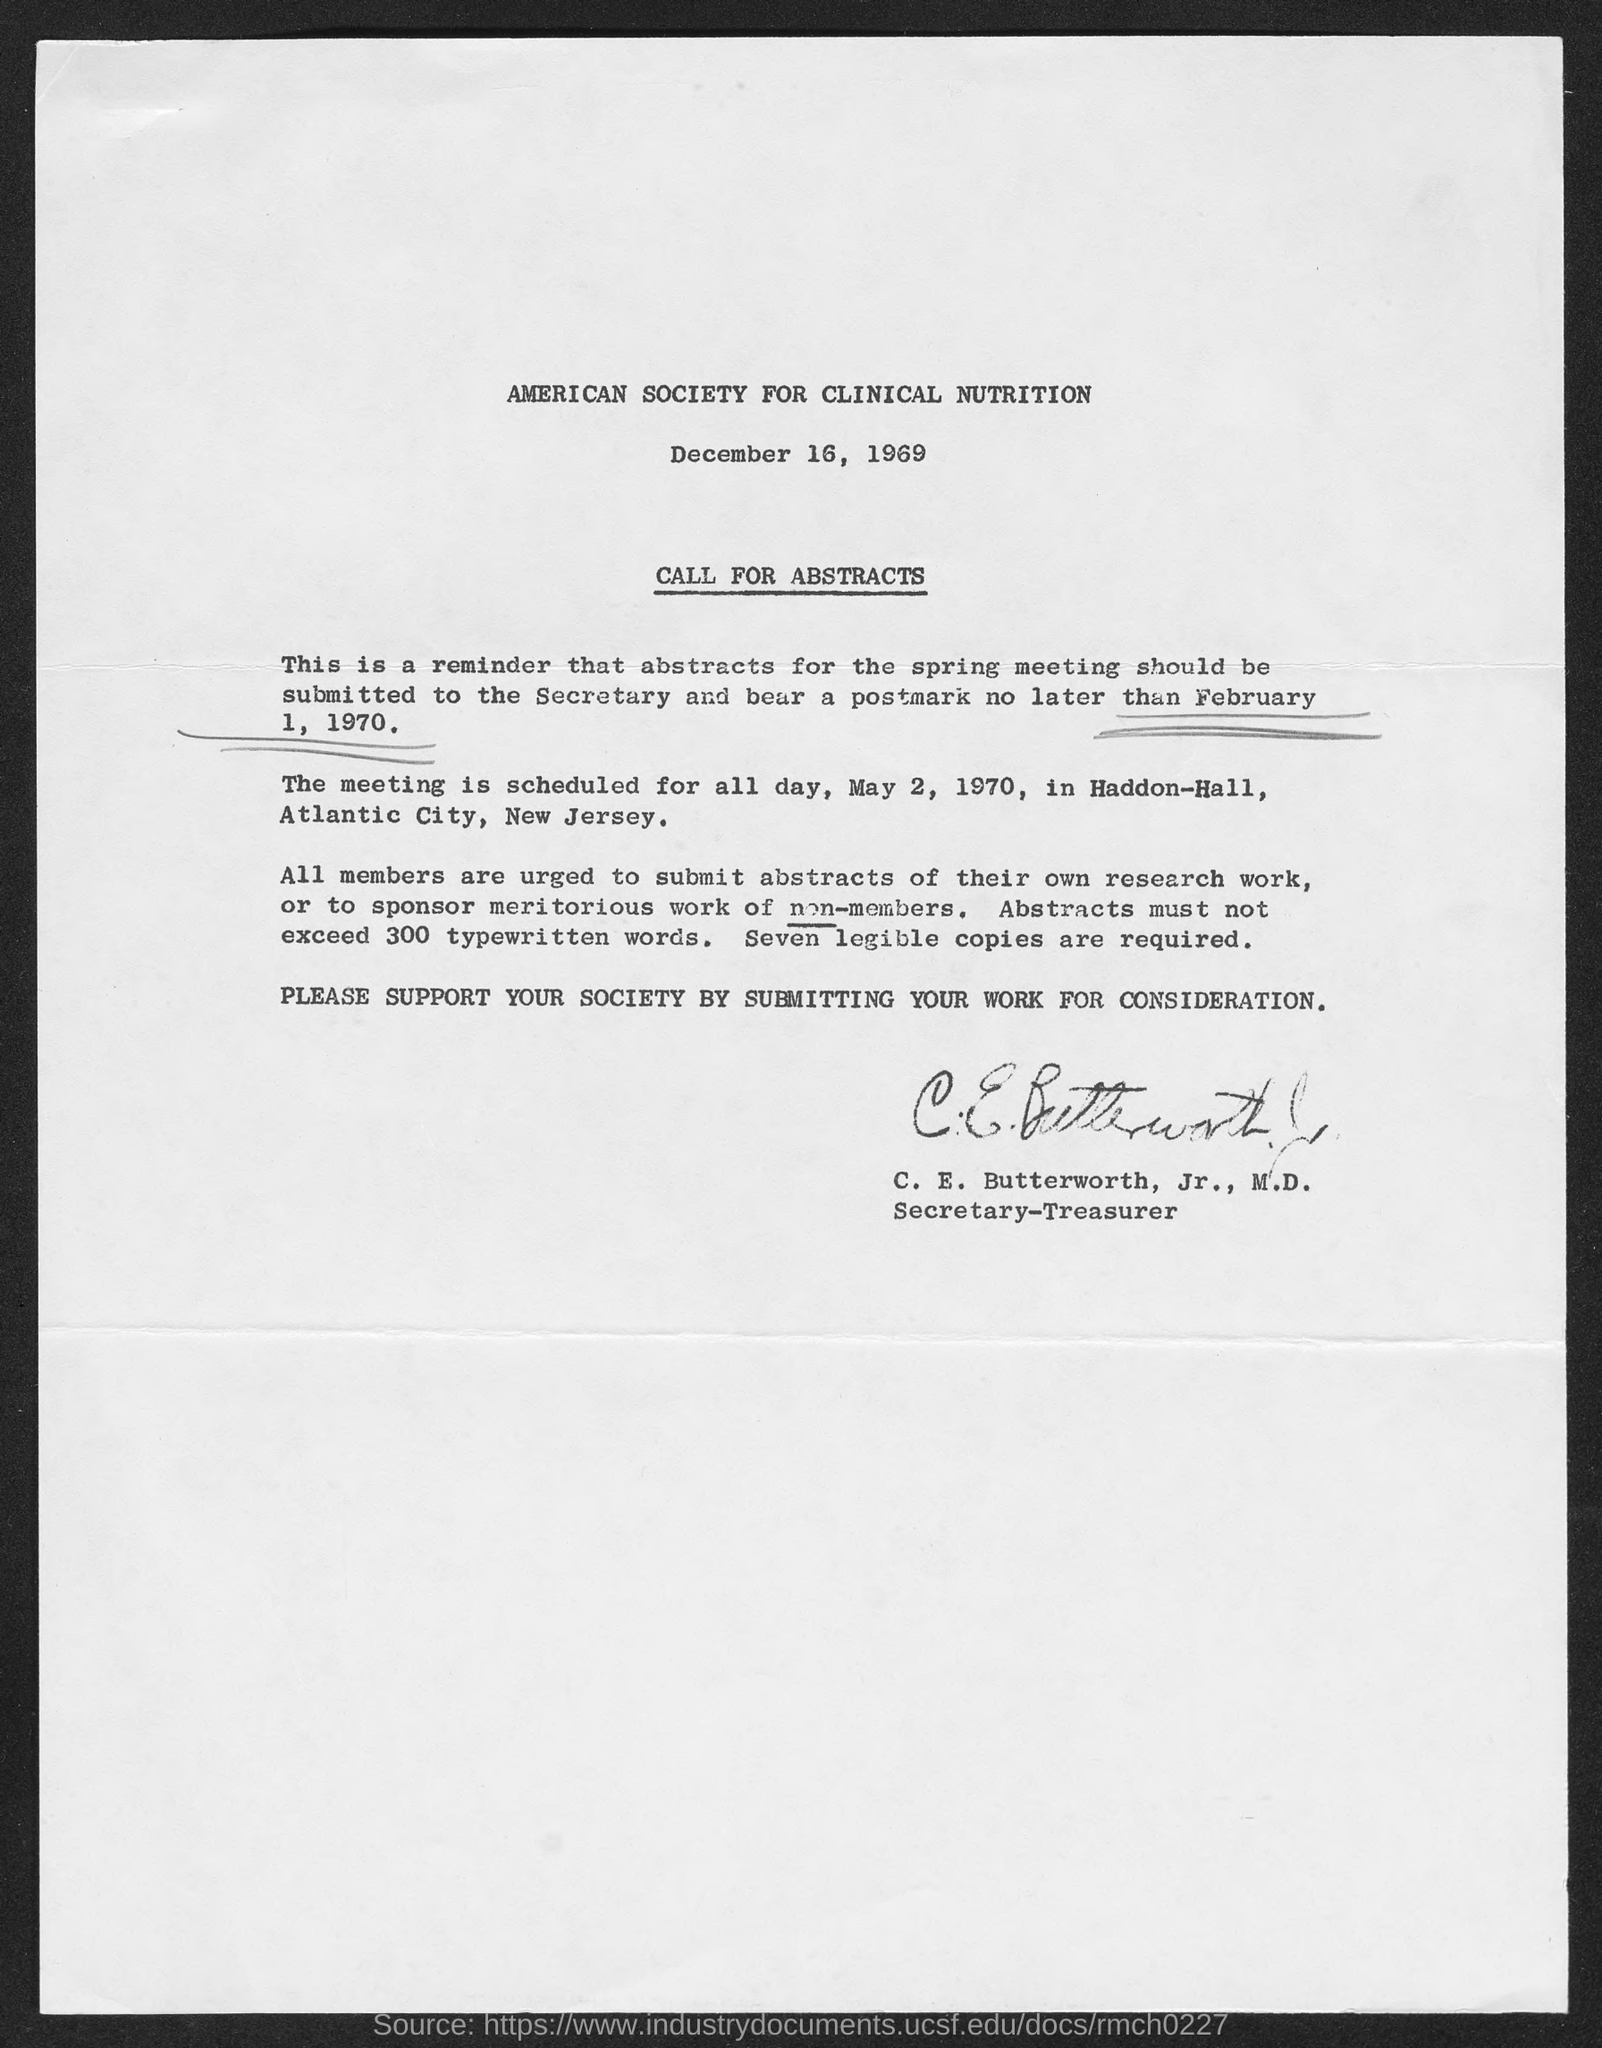Give some essential details in this illustration. The document has been signed by C. E. Butterworth, Jr., M.D. C.E. Butterworth, Jr., M.D. holds the designation of Secretary-Treasurer. It is required that abstracts do not exceed 300 typewritten words. Seven legible copies of abstracts are required. 